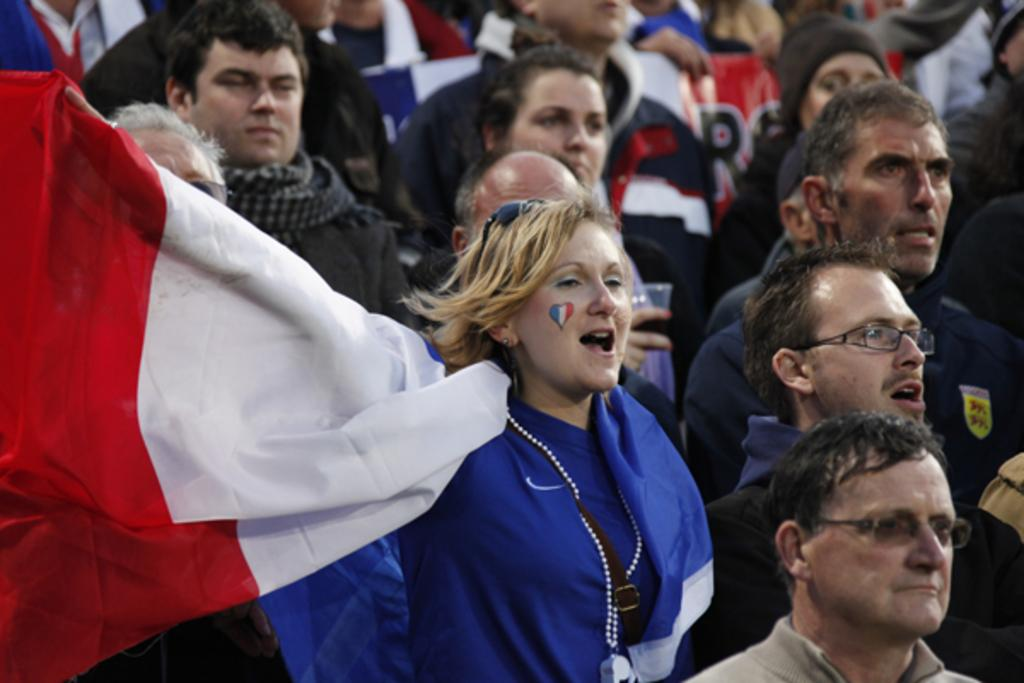What is the main subject of the image? The main subject of the image is a group of people. Can you describe anything else visible in the image? Yes, there is cloth on the left side of the image. What news is being discussed by the group of people in the image? There is no indication of any news being discussed in the image, as the focus is on the group of people and the cloth on the left side. 